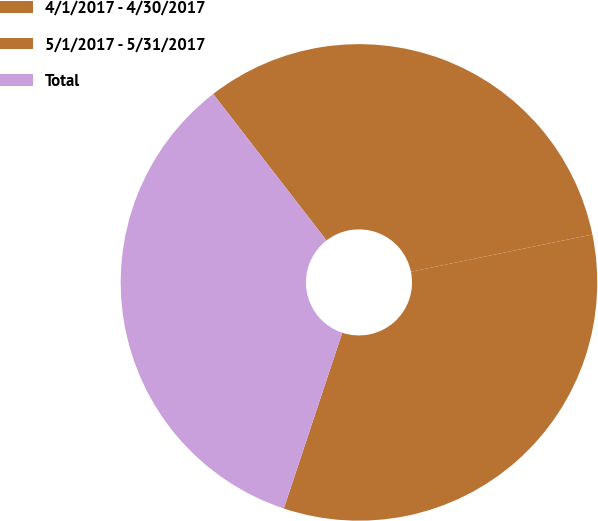Convert chart. <chart><loc_0><loc_0><loc_500><loc_500><pie_chart><fcel>4/1/2017 - 4/30/2017<fcel>5/1/2017 - 5/31/2017<fcel>Total<nl><fcel>32.26%<fcel>33.33%<fcel>34.41%<nl></chart> 